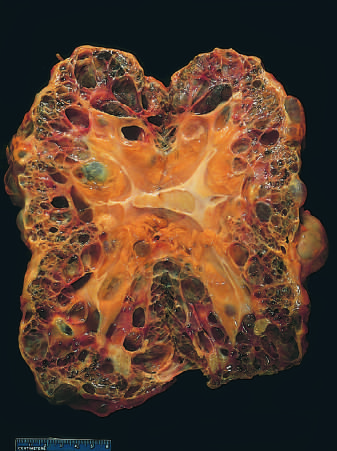what is centimeter rule shown for?
Answer the question using a single word or phrase. Scale 